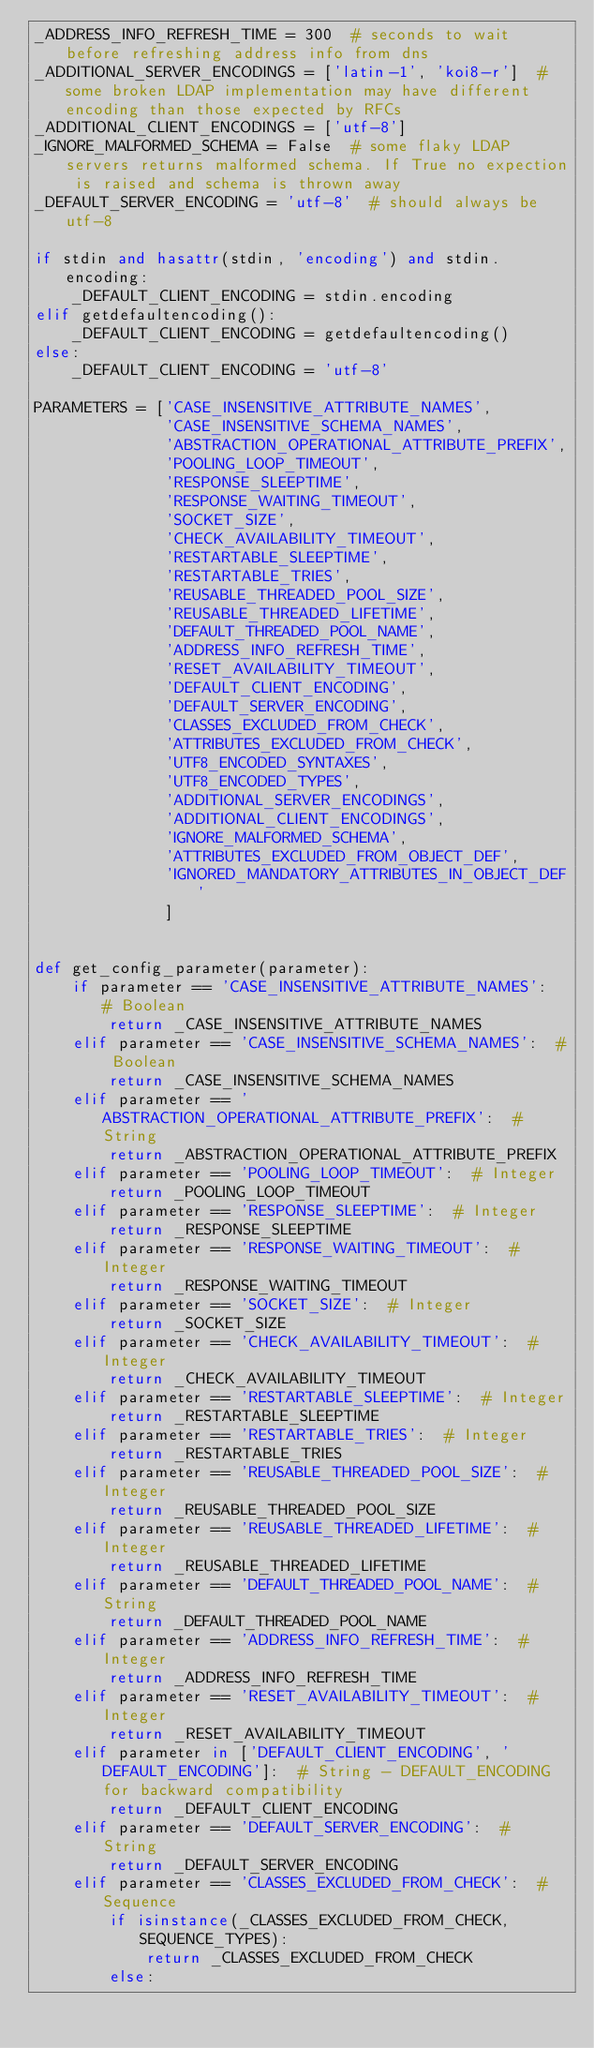Convert code to text. <code><loc_0><loc_0><loc_500><loc_500><_Python_>_ADDRESS_INFO_REFRESH_TIME = 300  # seconds to wait before refreshing address info from dns
_ADDITIONAL_SERVER_ENCODINGS = ['latin-1', 'koi8-r']  # some broken LDAP implementation may have different encoding than those expected by RFCs
_ADDITIONAL_CLIENT_ENCODINGS = ['utf-8']
_IGNORE_MALFORMED_SCHEMA = False  # some flaky LDAP servers returns malformed schema. If True no expection is raised and schema is thrown away
_DEFAULT_SERVER_ENCODING = 'utf-8'  # should always be utf-8

if stdin and hasattr(stdin, 'encoding') and stdin.encoding:
    _DEFAULT_CLIENT_ENCODING = stdin.encoding
elif getdefaultencoding():
    _DEFAULT_CLIENT_ENCODING = getdefaultencoding()
else:
    _DEFAULT_CLIENT_ENCODING = 'utf-8'

PARAMETERS = ['CASE_INSENSITIVE_ATTRIBUTE_NAMES',
              'CASE_INSENSITIVE_SCHEMA_NAMES',
              'ABSTRACTION_OPERATIONAL_ATTRIBUTE_PREFIX',
              'POOLING_LOOP_TIMEOUT',
              'RESPONSE_SLEEPTIME',
              'RESPONSE_WAITING_TIMEOUT',
              'SOCKET_SIZE',
              'CHECK_AVAILABILITY_TIMEOUT',
              'RESTARTABLE_SLEEPTIME',
              'RESTARTABLE_TRIES',
              'REUSABLE_THREADED_POOL_SIZE',
              'REUSABLE_THREADED_LIFETIME',
              'DEFAULT_THREADED_POOL_NAME',
              'ADDRESS_INFO_REFRESH_TIME',
              'RESET_AVAILABILITY_TIMEOUT',
              'DEFAULT_CLIENT_ENCODING',
              'DEFAULT_SERVER_ENCODING',
              'CLASSES_EXCLUDED_FROM_CHECK',
              'ATTRIBUTES_EXCLUDED_FROM_CHECK',
              'UTF8_ENCODED_SYNTAXES',
              'UTF8_ENCODED_TYPES',
              'ADDITIONAL_SERVER_ENCODINGS',
              'ADDITIONAL_CLIENT_ENCODINGS',
              'IGNORE_MALFORMED_SCHEMA',
              'ATTRIBUTES_EXCLUDED_FROM_OBJECT_DEF',
              'IGNORED_MANDATORY_ATTRIBUTES_IN_OBJECT_DEF'
              ]


def get_config_parameter(parameter):
    if parameter == 'CASE_INSENSITIVE_ATTRIBUTE_NAMES':  # Boolean
        return _CASE_INSENSITIVE_ATTRIBUTE_NAMES
    elif parameter == 'CASE_INSENSITIVE_SCHEMA_NAMES':  # Boolean
        return _CASE_INSENSITIVE_SCHEMA_NAMES
    elif parameter == 'ABSTRACTION_OPERATIONAL_ATTRIBUTE_PREFIX':  # String
        return _ABSTRACTION_OPERATIONAL_ATTRIBUTE_PREFIX
    elif parameter == 'POOLING_LOOP_TIMEOUT':  # Integer
        return _POOLING_LOOP_TIMEOUT
    elif parameter == 'RESPONSE_SLEEPTIME':  # Integer
        return _RESPONSE_SLEEPTIME
    elif parameter == 'RESPONSE_WAITING_TIMEOUT':  # Integer
        return _RESPONSE_WAITING_TIMEOUT
    elif parameter == 'SOCKET_SIZE':  # Integer
        return _SOCKET_SIZE
    elif parameter == 'CHECK_AVAILABILITY_TIMEOUT':  # Integer
        return _CHECK_AVAILABILITY_TIMEOUT
    elif parameter == 'RESTARTABLE_SLEEPTIME':  # Integer
        return _RESTARTABLE_SLEEPTIME
    elif parameter == 'RESTARTABLE_TRIES':  # Integer
        return _RESTARTABLE_TRIES
    elif parameter == 'REUSABLE_THREADED_POOL_SIZE':  # Integer
        return _REUSABLE_THREADED_POOL_SIZE
    elif parameter == 'REUSABLE_THREADED_LIFETIME':  # Integer
        return _REUSABLE_THREADED_LIFETIME
    elif parameter == 'DEFAULT_THREADED_POOL_NAME':  # String
        return _DEFAULT_THREADED_POOL_NAME
    elif parameter == 'ADDRESS_INFO_REFRESH_TIME':  # Integer
        return _ADDRESS_INFO_REFRESH_TIME
    elif parameter == 'RESET_AVAILABILITY_TIMEOUT':  # Integer
        return _RESET_AVAILABILITY_TIMEOUT
    elif parameter in ['DEFAULT_CLIENT_ENCODING', 'DEFAULT_ENCODING']:  # String - DEFAULT_ENCODING for backward compatibility
        return _DEFAULT_CLIENT_ENCODING
    elif parameter == 'DEFAULT_SERVER_ENCODING':  # String
        return _DEFAULT_SERVER_ENCODING
    elif parameter == 'CLASSES_EXCLUDED_FROM_CHECK':  # Sequence
        if isinstance(_CLASSES_EXCLUDED_FROM_CHECK, SEQUENCE_TYPES):
            return _CLASSES_EXCLUDED_FROM_CHECK
        else:</code> 